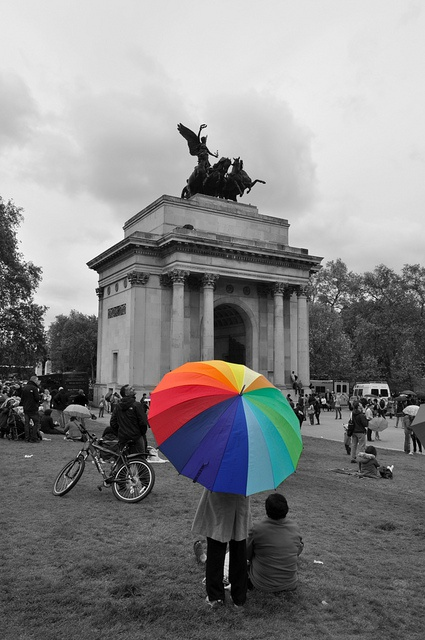Describe the objects in this image and their specific colors. I can see umbrella in lightgray, navy, teal, and brown tones, people in lightgray, black, gray, and darkgray tones, people in lightgray, black, and gray tones, people in lightgray, black, gray, darkgray, and navy tones, and bicycle in lightgray, black, gray, and darkgray tones in this image. 